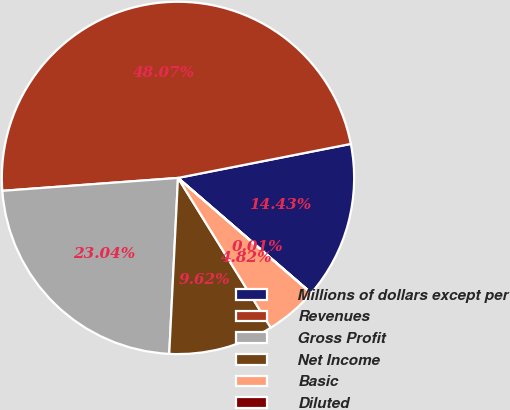Convert chart. <chart><loc_0><loc_0><loc_500><loc_500><pie_chart><fcel>Millions of dollars except per<fcel>Revenues<fcel>Gross Profit<fcel>Net Income<fcel>Basic<fcel>Diluted<nl><fcel>14.43%<fcel>48.07%<fcel>23.04%<fcel>9.62%<fcel>4.82%<fcel>0.01%<nl></chart> 